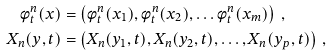Convert formula to latex. <formula><loc_0><loc_0><loc_500><loc_500>\phi _ { t } ^ { n } ( x ) & = \left ( \phi _ { t } ^ { n } ( x _ { 1 } ) , \phi _ { t } ^ { n } ( x _ { 2 } ) , \dots \phi _ { t } ^ { n } ( x _ { m } ) \right ) \, , \\ X _ { n } ( y , t ) & = \left ( X _ { n } ( y _ { 1 } , t ) , X _ { n } ( y _ { 2 } , t ) , \dots , X _ { n } ( y _ { p } , t ) \right ) \, ,</formula> 